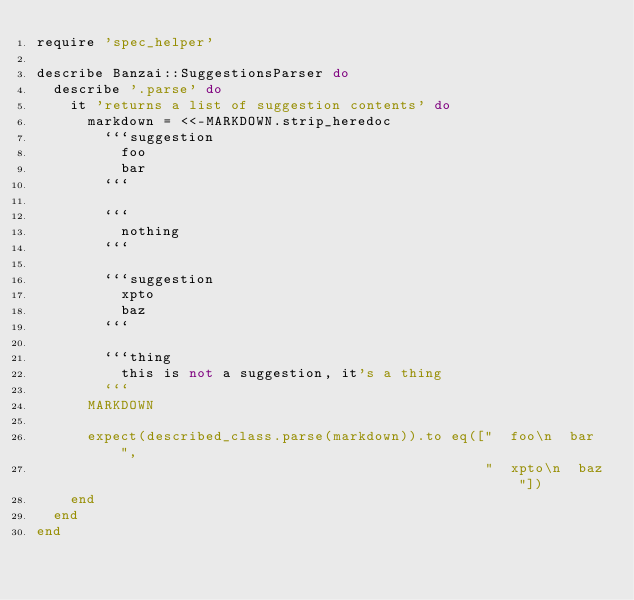Convert code to text. <code><loc_0><loc_0><loc_500><loc_500><_Ruby_>require 'spec_helper'

describe Banzai::SuggestionsParser do
  describe '.parse' do
    it 'returns a list of suggestion contents' do
      markdown = <<-MARKDOWN.strip_heredoc
        ```suggestion
          foo
          bar
        ```

        ```
          nothing
        ```

        ```suggestion
          xpto
          baz
        ```

        ```thing
          this is not a suggestion, it's a thing
        ```
      MARKDOWN

      expect(described_class.parse(markdown)).to eq(["  foo\n  bar",
                                                     "  xpto\n  baz"])
    end
  end
end
</code> 